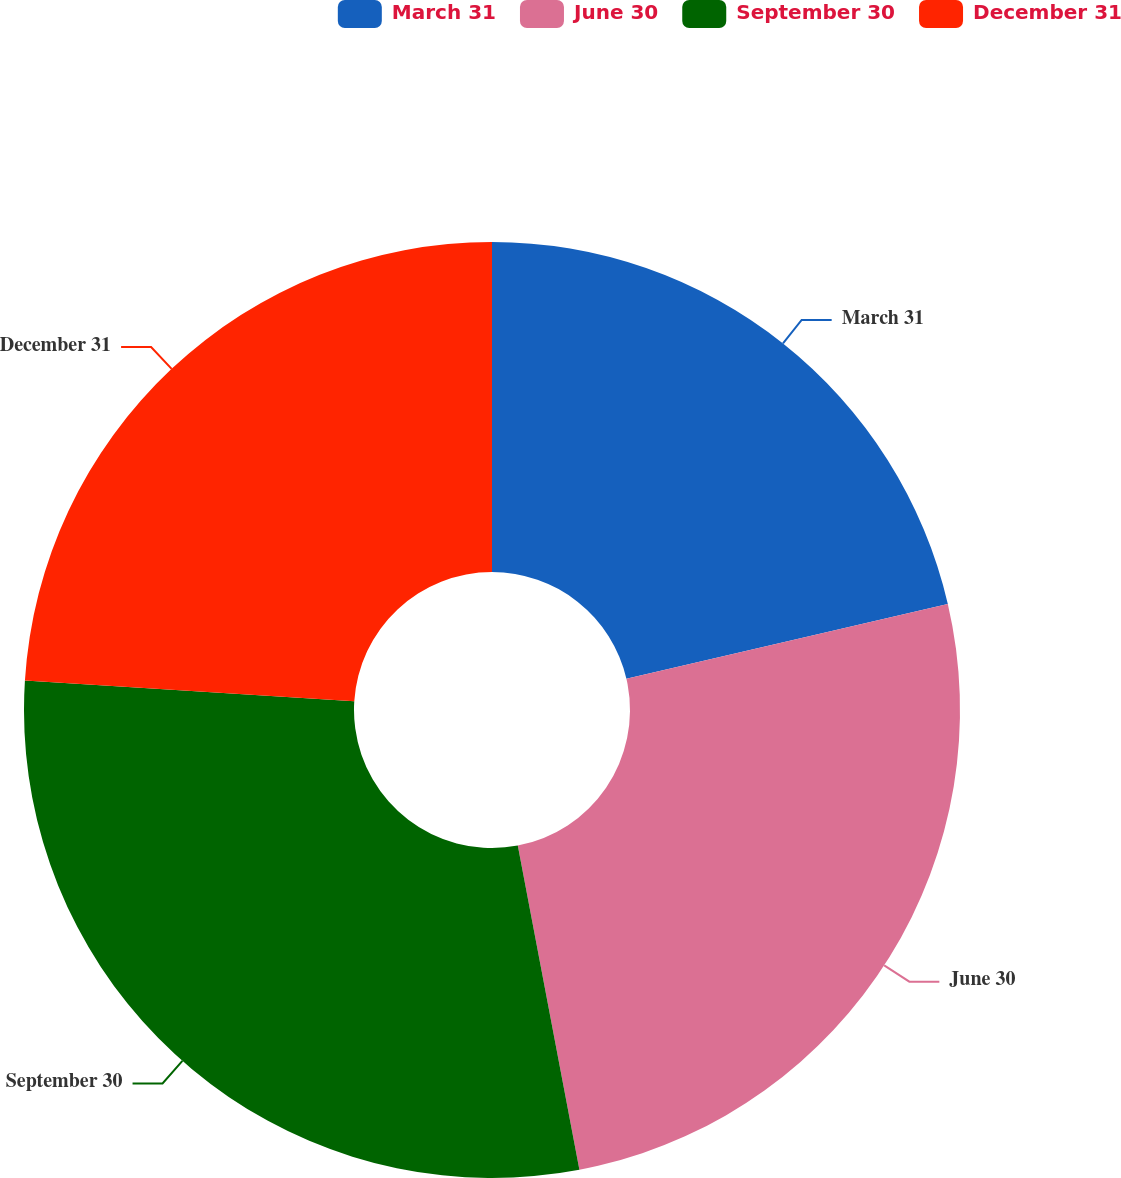<chart> <loc_0><loc_0><loc_500><loc_500><pie_chart><fcel>March 31<fcel>June 30<fcel>September 30<fcel>December 31<nl><fcel>21.36%<fcel>25.65%<fcel>28.99%<fcel>24.0%<nl></chart> 